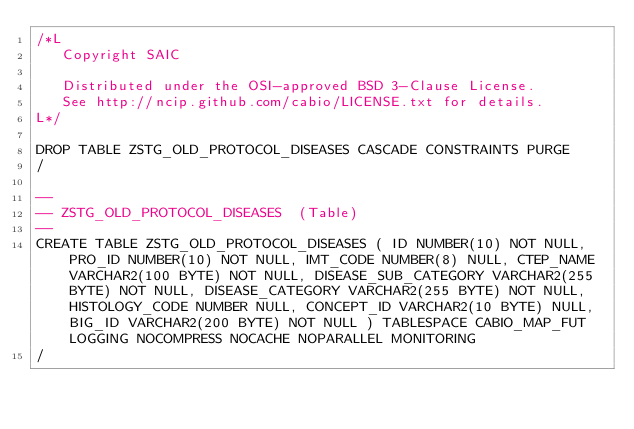Convert code to text. <code><loc_0><loc_0><loc_500><loc_500><_SQL_>/*L
   Copyright SAIC

   Distributed under the OSI-approved BSD 3-Clause License.
   See http://ncip.github.com/cabio/LICENSE.txt for details.
L*/

DROP TABLE ZSTG_OLD_PROTOCOL_DISEASES CASCADE CONSTRAINTS PURGE
/

--
-- ZSTG_OLD_PROTOCOL_DISEASES  (Table) 
--
CREATE TABLE ZSTG_OLD_PROTOCOL_DISEASES ( ID NUMBER(10) NOT NULL, PRO_ID NUMBER(10) NOT NULL, IMT_CODE NUMBER(8) NULL, CTEP_NAME VARCHAR2(100 BYTE) NOT NULL, DISEASE_SUB_CATEGORY VARCHAR2(255 BYTE) NOT NULL, DISEASE_CATEGORY VARCHAR2(255 BYTE) NOT NULL, HISTOLOGY_CODE NUMBER NULL, CONCEPT_ID VARCHAR2(10 BYTE) NULL, BIG_ID VARCHAR2(200 BYTE) NOT NULL ) TABLESPACE CABIO_MAP_FUT LOGGING NOCOMPRESS NOCACHE NOPARALLEL MONITORING
/


</code> 